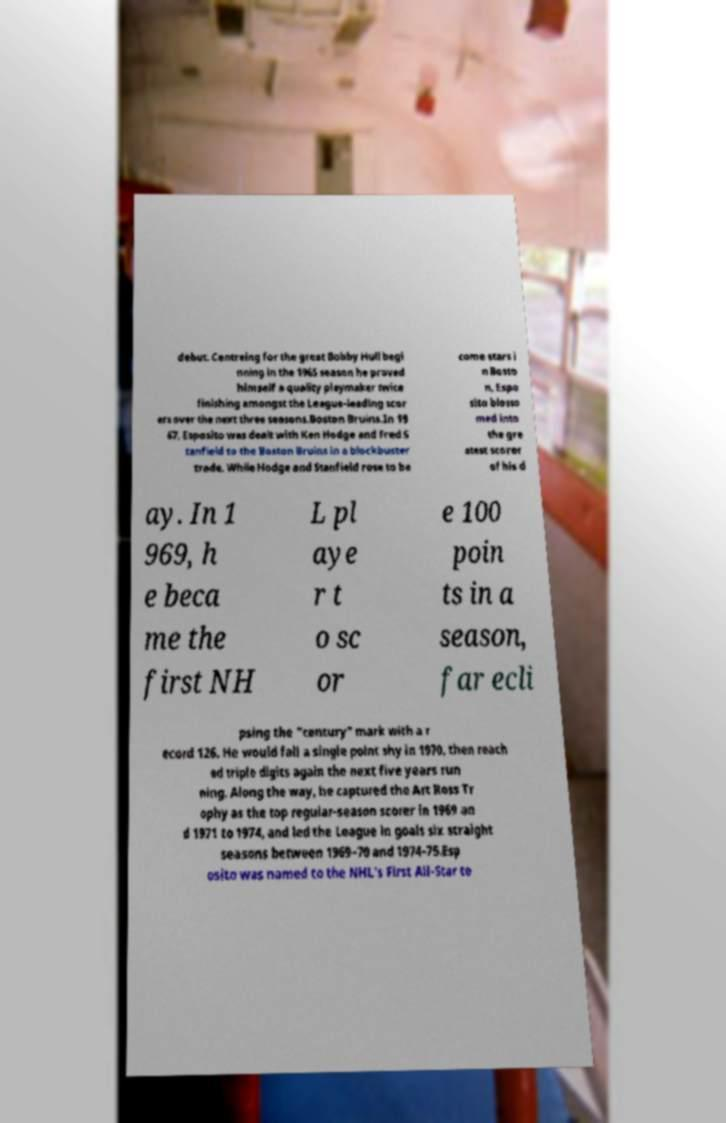Please read and relay the text visible in this image. What does it say? debut. Centreing for the great Bobby Hull begi nning in the 1965 season he proved himself a quality playmaker twice finishing amongst the League-leading scor ers over the next three seasons.Boston Bruins.In 19 67, Esposito was dealt with Ken Hodge and Fred S tanfield to the Boston Bruins in a blockbuster trade. While Hodge and Stanfield rose to be come stars i n Bosto n, Espo sito blosso med into the gre atest scorer of his d ay. In 1 969, h e beca me the first NH L pl aye r t o sc or e 100 poin ts in a season, far ecli psing the "century" mark with a r ecord 126. He would fall a single point shy in 1970, then reach ed triple digits again the next five years run ning. Along the way, he captured the Art Ross Tr ophy as the top regular-season scorer in 1969 an d 1971 to 1974, and led the League in goals six straight seasons between 1969–70 and 1974–75.Esp osito was named to the NHL's First All-Star te 